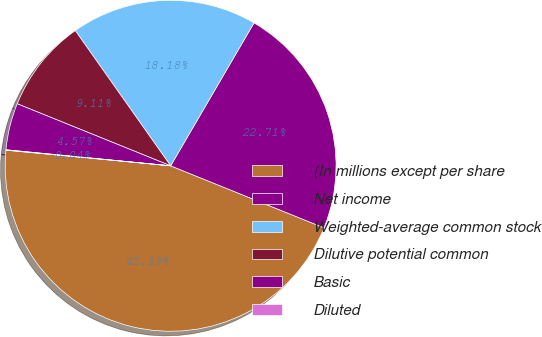Convert chart. <chart><loc_0><loc_0><loc_500><loc_500><pie_chart><fcel>(In millions except per share<fcel>Net income<fcel>Weighted-average common stock<fcel>Dilutive potential common<fcel>Basic<fcel>Diluted<nl><fcel>45.39%<fcel>22.71%<fcel>18.18%<fcel>9.11%<fcel>4.57%<fcel>0.04%<nl></chart> 